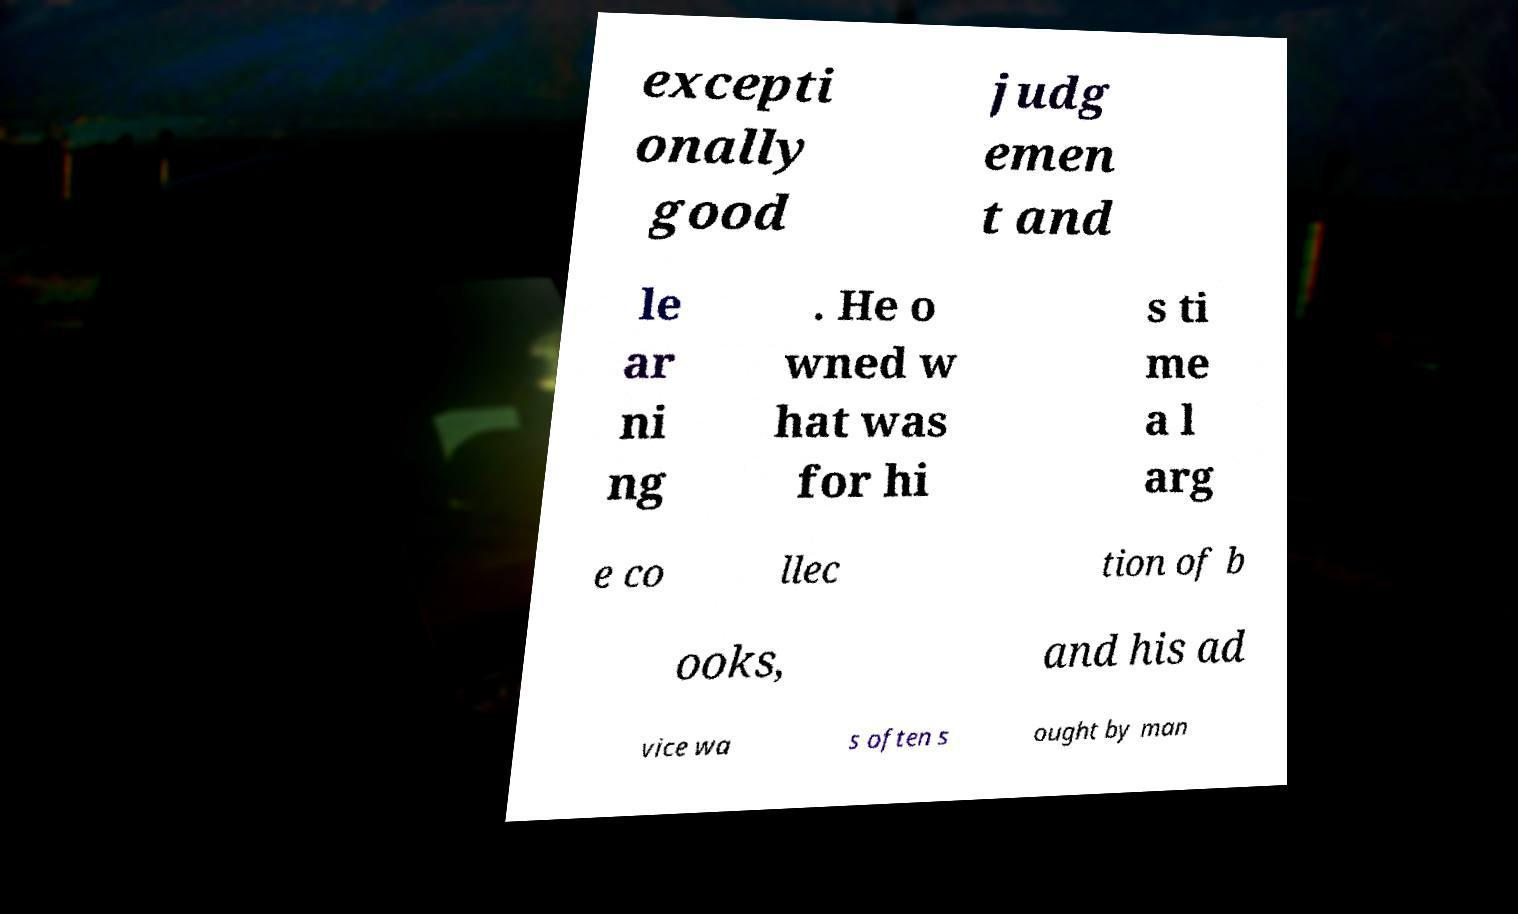Can you read and provide the text displayed in the image?This photo seems to have some interesting text. Can you extract and type it out for me? excepti onally good judg emen t and le ar ni ng . He o wned w hat was for hi s ti me a l arg e co llec tion of b ooks, and his ad vice wa s often s ought by man 